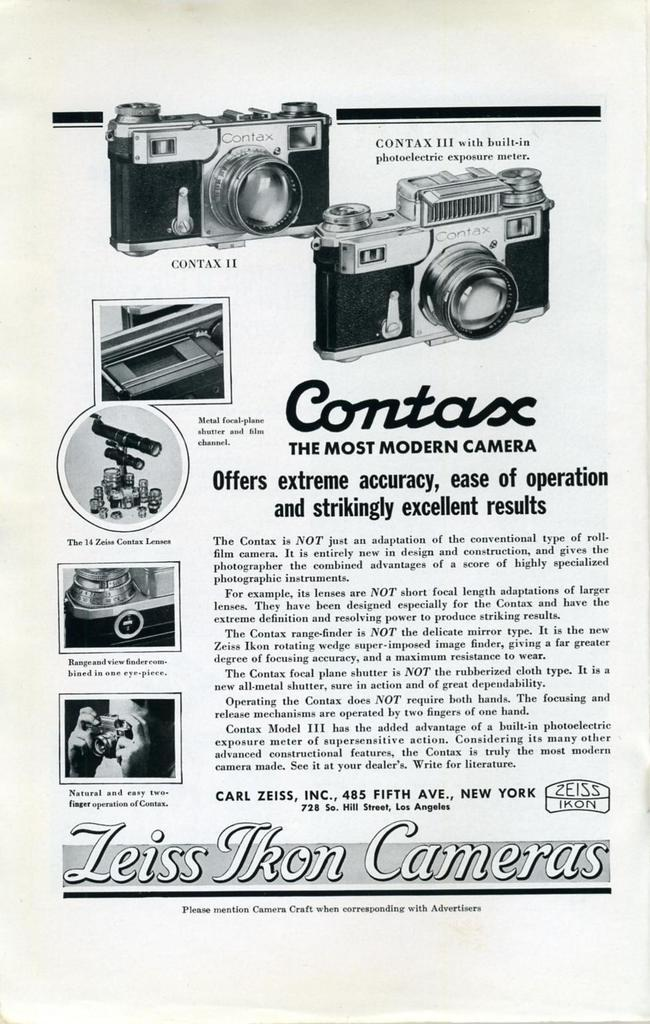What is written or drawn on the paper in the image? There is text on the paper in the image. What type of objects are depicted on the paper? There are cameras depicted on the paper. Are there any other objects or elements present on the paper? Yes, there are other objects present on the paper. Can you see any fangs on the cameras depicted on the paper? There are no fangs present on the cameras depicted on the paper, as cameras do not have fangs. What type of liquid is being used to write the text on the paper? There is no information about the writing instrument used to create the text on the paper, so we cannot determine if it is a liquid or not. 